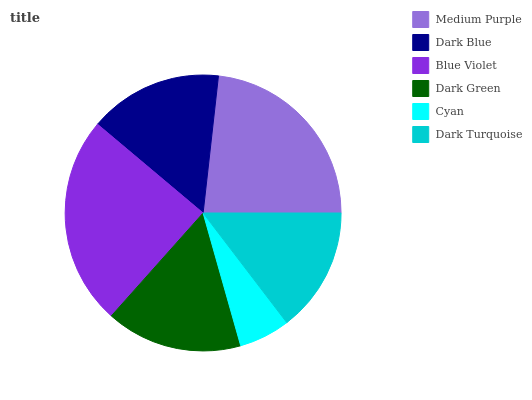Is Cyan the minimum?
Answer yes or no. Yes. Is Blue Violet the maximum?
Answer yes or no. Yes. Is Dark Blue the minimum?
Answer yes or no. No. Is Dark Blue the maximum?
Answer yes or no. No. Is Medium Purple greater than Dark Blue?
Answer yes or no. Yes. Is Dark Blue less than Medium Purple?
Answer yes or no. Yes. Is Dark Blue greater than Medium Purple?
Answer yes or no. No. Is Medium Purple less than Dark Blue?
Answer yes or no. No. Is Dark Green the high median?
Answer yes or no. Yes. Is Dark Blue the low median?
Answer yes or no. Yes. Is Cyan the high median?
Answer yes or no. No. Is Dark Turquoise the low median?
Answer yes or no. No. 